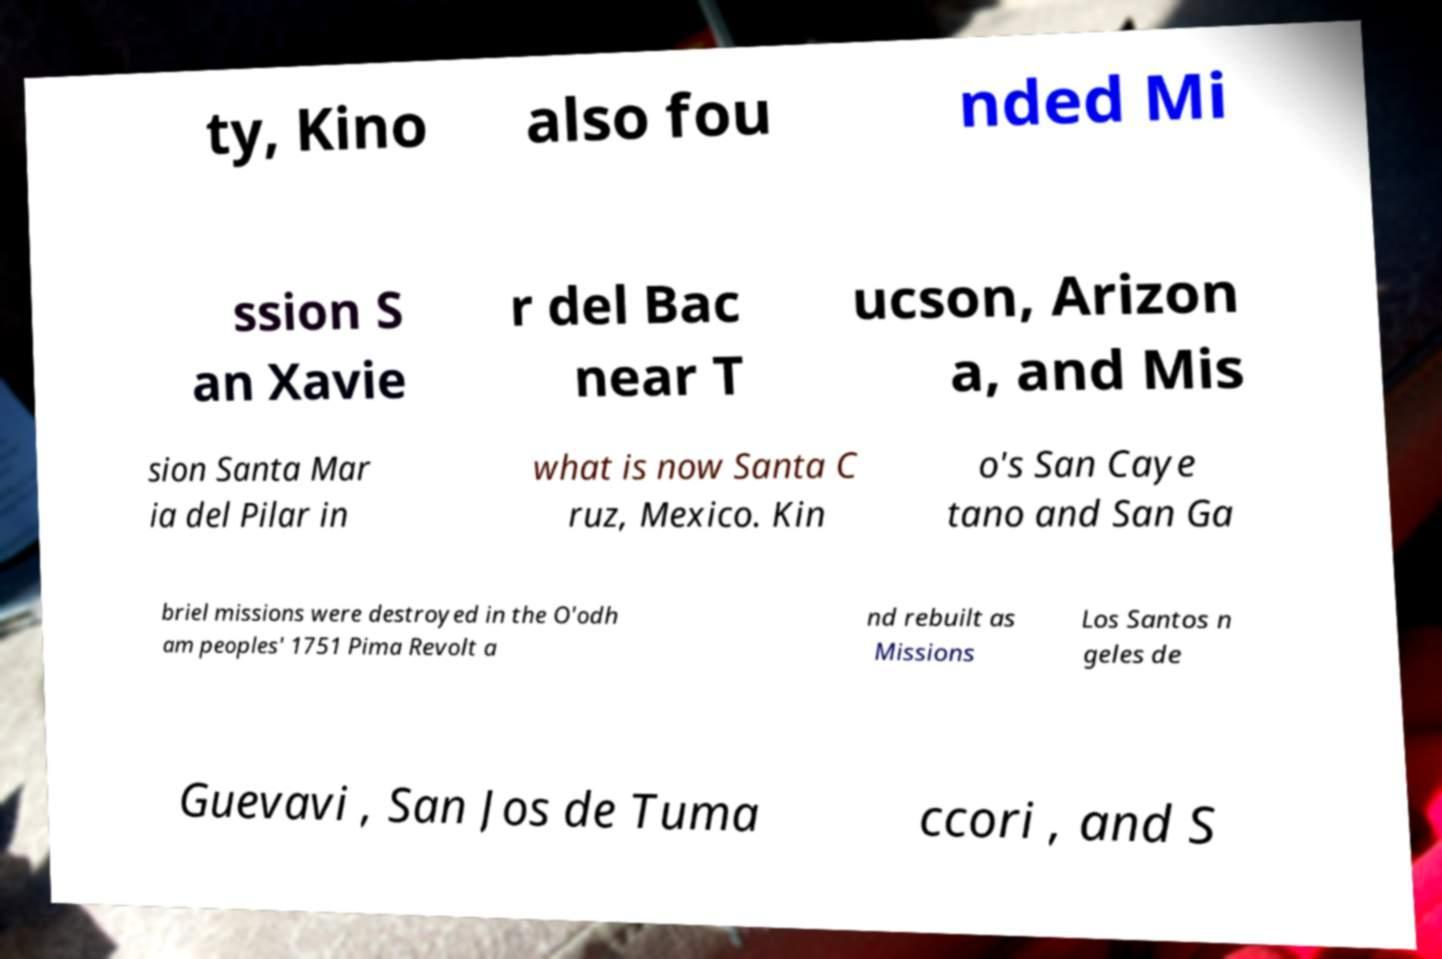Could you extract and type out the text from this image? ty, Kino also fou nded Mi ssion S an Xavie r del Bac near T ucson, Arizon a, and Mis sion Santa Mar ia del Pilar in what is now Santa C ruz, Mexico. Kin o's San Caye tano and San Ga briel missions were destroyed in the O'odh am peoples' 1751 Pima Revolt a nd rebuilt as Missions Los Santos n geles de Guevavi , San Jos de Tuma ccori , and S 